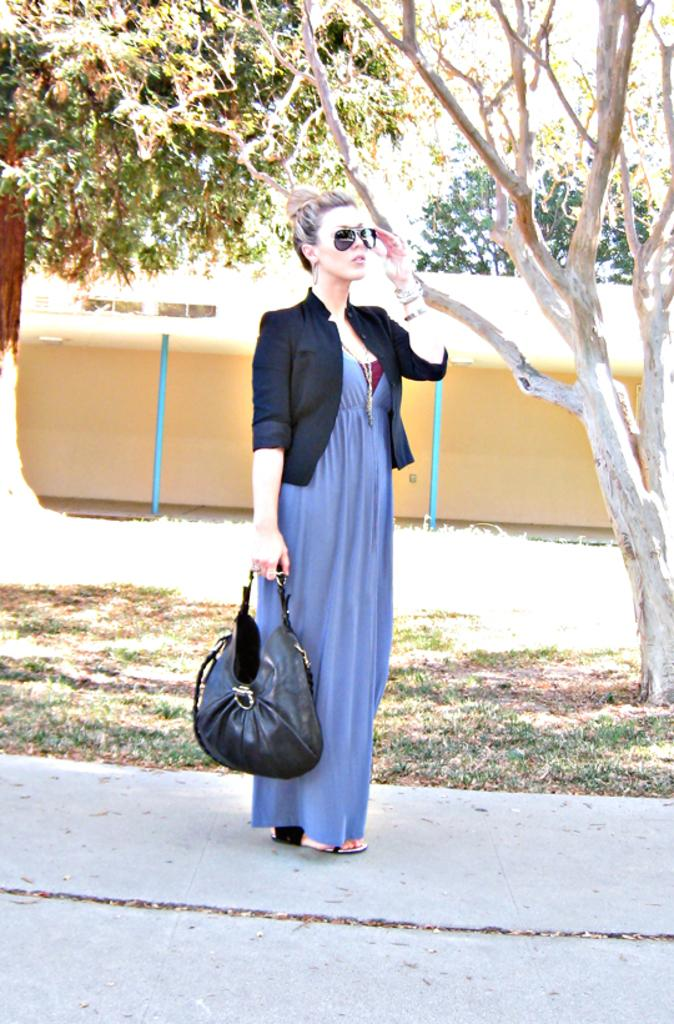Who is present in the image? There is a woman in the image. What is the woman doing in the image? The woman is standing in the image. What is the woman holding in her right hand? The woman is holding a black color bag in her right hand. What can be seen in the background of the image? There are trees in the background of the image. What does the caption on the bag say in the image? There is no caption visible on the bag in the image. Is the woman walking in a park in the image? The image does not specify the location as a park, and there is no indication of the woman walking. 